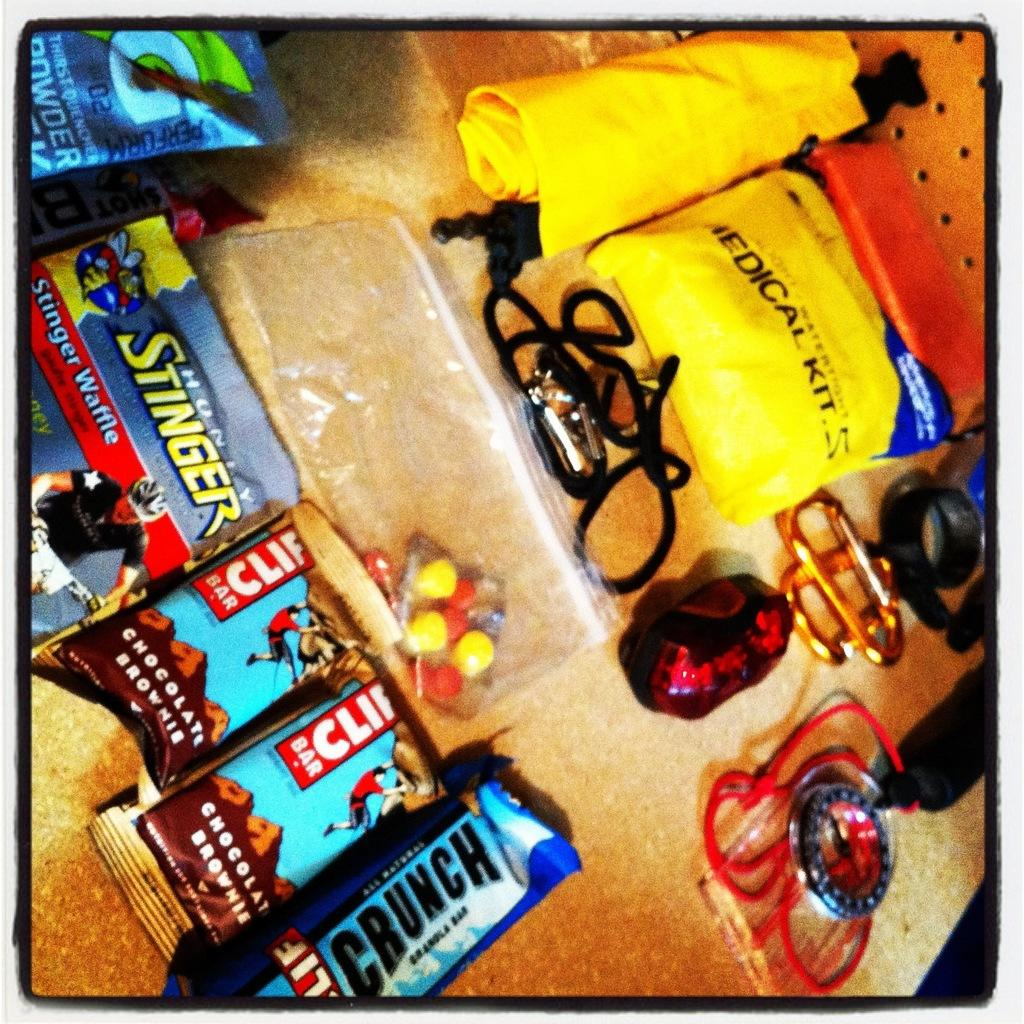What items can be seen in the image? There are packets, threads, gems, chocolates,ocolates, and a watch in the image. What else is present in the image besides these items? There are other objects in the image, but their specific details are not mentioned in the provided facts. What object is at the bottom of the image? There is an object at the bottom of the image that looks like a table. Can you tell me how many family members are running in the shop in the image? There is no information about family members or a shop in the image; it contains packets, threads, gems, chocolates, a watch, other objects, and a table. 